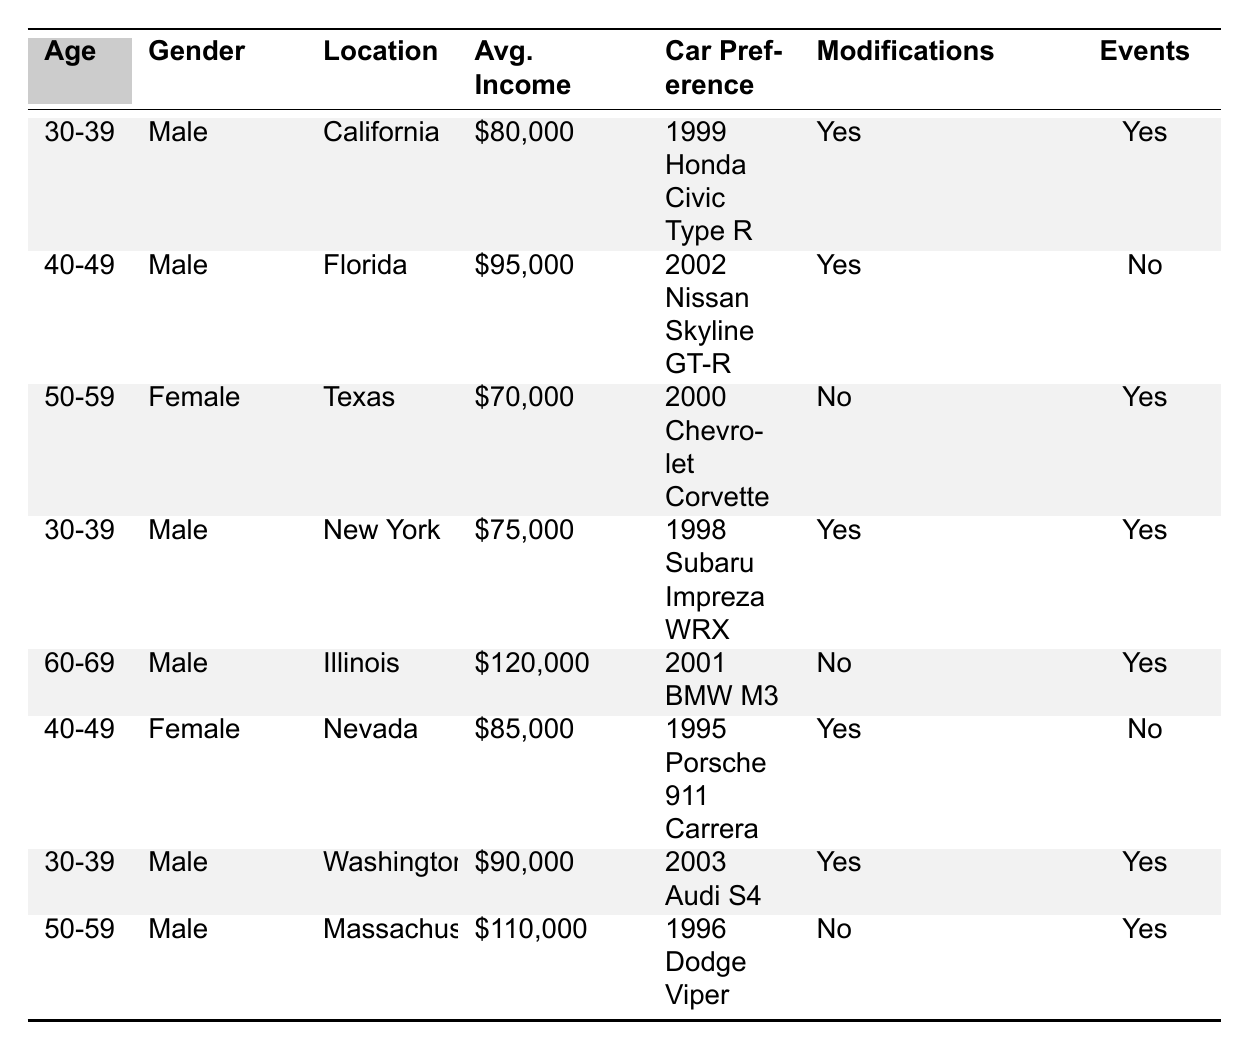What is the average income of female car owners in the dataset? There are two female car owners: one with an income of $70,000 and the other with $85,000. Their average income is calculated by summing these values (70,000 + 85,000 = 155,000) and then dividing by the number of female owners (2). Thus, the average income is $155,000 / 2 = $77,500.
Answer: $77,500 Which car model is preferred by the oldest group of owners (60-69 years old)? Only one owner falls into the age range of 60-69, which is a male from Illinois. His car model preference is a 2001 BMW M3.
Answer: 2001 BMW M3 How many car owners participate in events but do not modify their cars? Looking at the table, there are two owners who do not modify their cars (one in Texas and one in Massachusetts) and both participate in events. Therefore, the total count is 2.
Answer: 2 Is there a car model preferred by both male and female owners? The car models preferred by male owners are the 1999 Honda Civic Type R, 2002 Nissan Skyline GT-R, 1998 Subaru Impreza WRX, 2001 BMW M3, 2003 Audi S4, and 1996 Dodge Viper. The female owners prefer the 2000 Chevrolet Corvette and 1995 Porsche 911 Carrera. There are no common models between both genders.
Answer: No What is the total average income of all car owners in the dataset? There are eight owners, with average incomes of $80,000, $95,000, $70,000, $75,000, $120,000, $85,000, $90,000, and $110,000. To find the total average income, we sum these values: (80,000 + 95,000 + 70,000 + 75,000 + 120,000 + 85,000 + 90,000 + 110,000 = 735,000). Dividing this total by the number of owners (8), we get $735,000 / 8 = $91,875.
Answer: $91,875 Which state has the highest average income among car owners in this dataset? The highest income in the dataset belongs to the male owner from Illinois at $120,000. Since no other owner has a higher income, Illinois is the state with the highest average income.
Answer: Illinois How many male owners are interested in modifications? From the table, the male owners who are interested in modifications are those from California, Florida, New York, Washington, and Illinois, totaling five male owners.
Answer: 5 What percentage of the owners participate in events? Five out of the eight owners participate in events, leading to the calculation of the percentage: (5 / 8) * 100 = 62.5%. Therefore, 62.5% of the owners participate in events.
Answer: 62.5% Is the average income of owners who prefer modifying their cars greater than or less than $90,000? The average incomes of the owners interested in modifications are $80,000 (California), $95,000 (Florida), $75,000 (New York), $90,000 (Washington), and an income of $85,000 (Nevada). To calculate the average: add them (80,000 + 95,000 + 75,000 + 90,000 + 85,000 = 425,000), then divide by 5 (425,000 / 5 = $85,000), which is less than $90,000.
Answer: Less than $90,000 What is the most preferred car model among owners aged 30-39? The owners aged 30-39 who prefer car models are from California (1999 Honda Civic Type R), New York (1998 Subaru Impreza WRX), and Washington (2003 Audi S4). Each model is unique, so there is no most preferred model among this age group.
Answer: No preference evident 